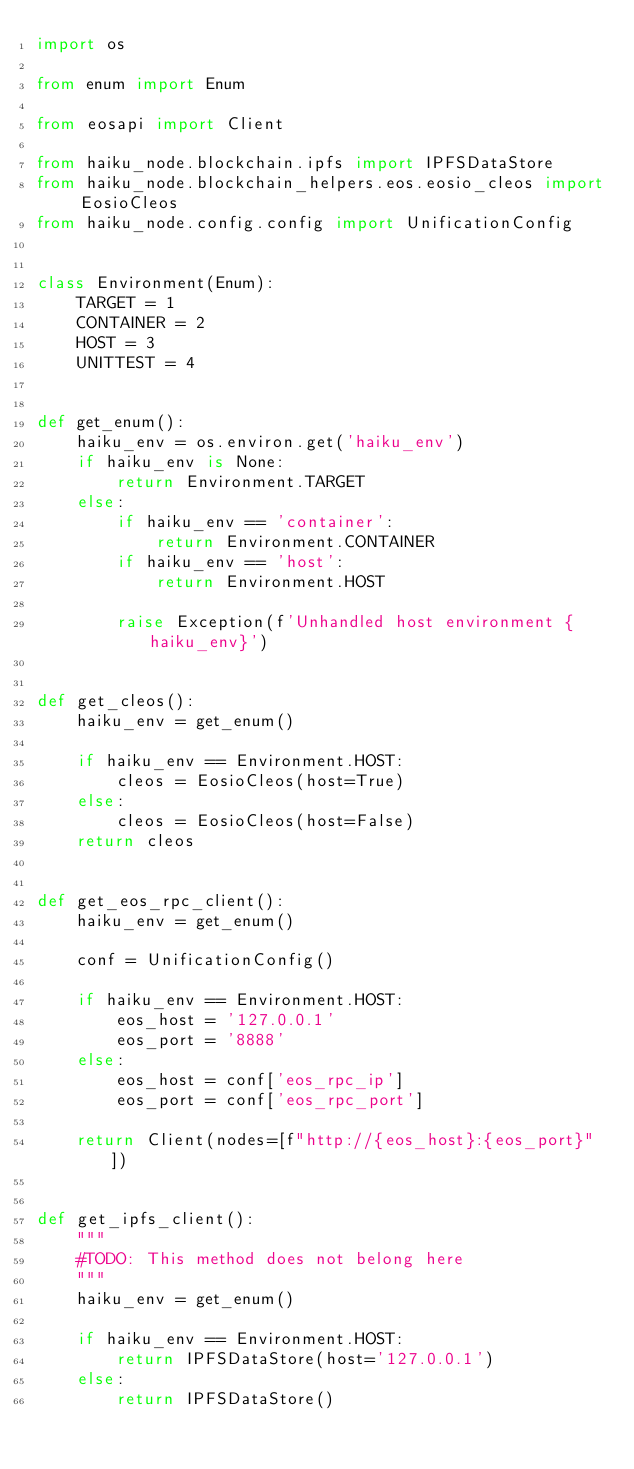<code> <loc_0><loc_0><loc_500><loc_500><_Python_>import os

from enum import Enum

from eosapi import Client

from haiku_node.blockchain.ipfs import IPFSDataStore
from haiku_node.blockchain_helpers.eos.eosio_cleos import EosioCleos
from haiku_node.config.config import UnificationConfig


class Environment(Enum):
    TARGET = 1
    CONTAINER = 2
    HOST = 3
    UNITTEST = 4


def get_enum():
    haiku_env = os.environ.get('haiku_env')
    if haiku_env is None:
        return Environment.TARGET
    else:
        if haiku_env == 'container':
            return Environment.CONTAINER
        if haiku_env == 'host':
            return Environment.HOST

        raise Exception(f'Unhandled host environment {haiku_env}')


def get_cleos():
    haiku_env = get_enum()

    if haiku_env == Environment.HOST:
        cleos = EosioCleos(host=True)
    else:
        cleos = EosioCleos(host=False)
    return cleos


def get_eos_rpc_client():
    haiku_env = get_enum()

    conf = UnificationConfig()

    if haiku_env == Environment.HOST:
        eos_host = '127.0.0.1'
        eos_port = '8888'
    else:
        eos_host = conf['eos_rpc_ip']
        eos_port = conf['eos_rpc_port']

    return Client(nodes=[f"http://{eos_host}:{eos_port}"])


def get_ipfs_client():
    """
    #TODO: This method does not belong here
    """
    haiku_env = get_enum()

    if haiku_env == Environment.HOST:
        return IPFSDataStore(host='127.0.0.1')
    else:
        return IPFSDataStore()
</code> 